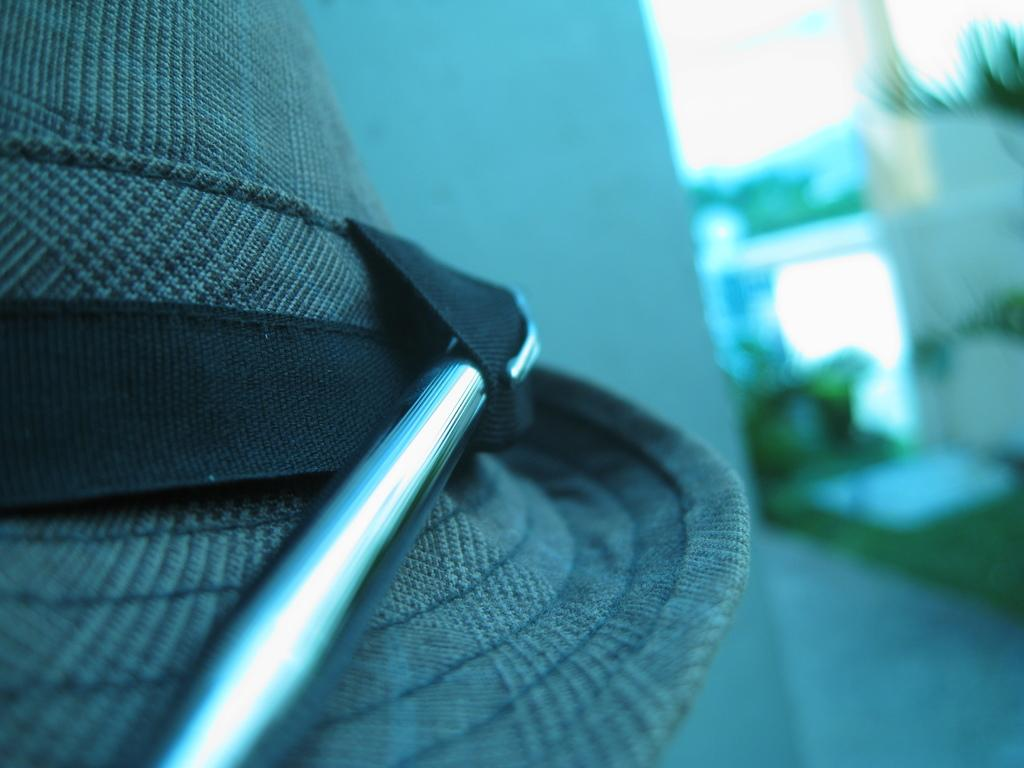What is present in the foreground of the image? There is a wall in the image. What can be seen in the background of the image? There are plants and another wall in the background of the image. What type of payment is being made in the image? There is no payment being made in the image; it only features a wall and plants in the background. 